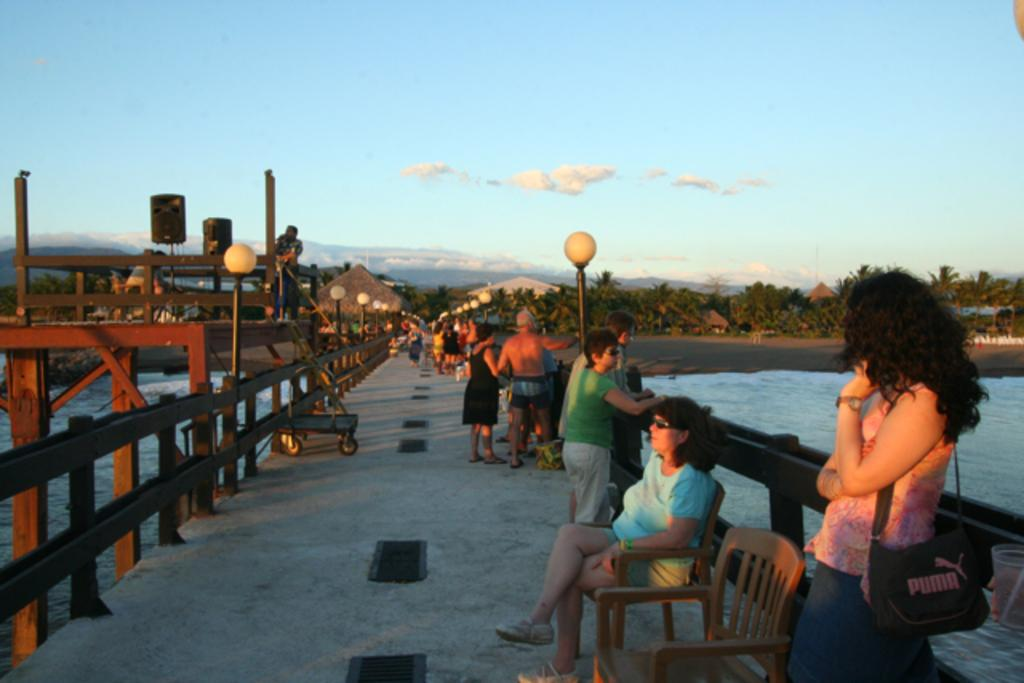What are the people in the image doing? The people in the image are on a bridge. What can be seen in the sky in the image? The sky is visible in the image. What type of vegetation is present in the image? Trees are present in the image. What type of structures can be seen in the image? Huts are visible in the image. What is the reason for the sleet in the image? There is no mention of sleet in the image, so it cannot be determined as a reason for anything. Is there a fire visible in the image? There is no fire present in the image. 